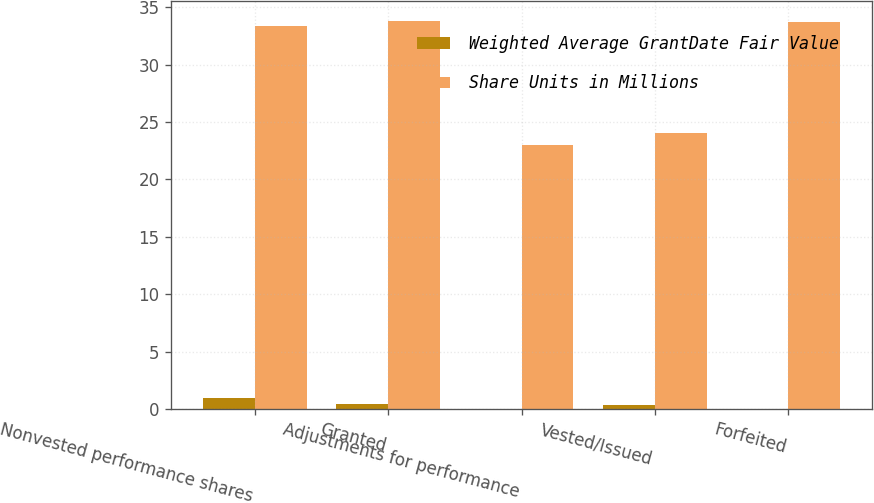Convert chart. <chart><loc_0><loc_0><loc_500><loc_500><stacked_bar_chart><ecel><fcel>Nonvested performance shares<fcel>Granted<fcel>Adjustments for performance<fcel>Vested/Issued<fcel>Forfeited<nl><fcel>Weighted Average GrantDate Fair Value<fcel>1<fcel>0.48<fcel>0.01<fcel>0.33<fcel>0.02<nl><fcel>Share Units in Millions<fcel>33.4<fcel>33.82<fcel>22.98<fcel>24.08<fcel>33.69<nl></chart> 